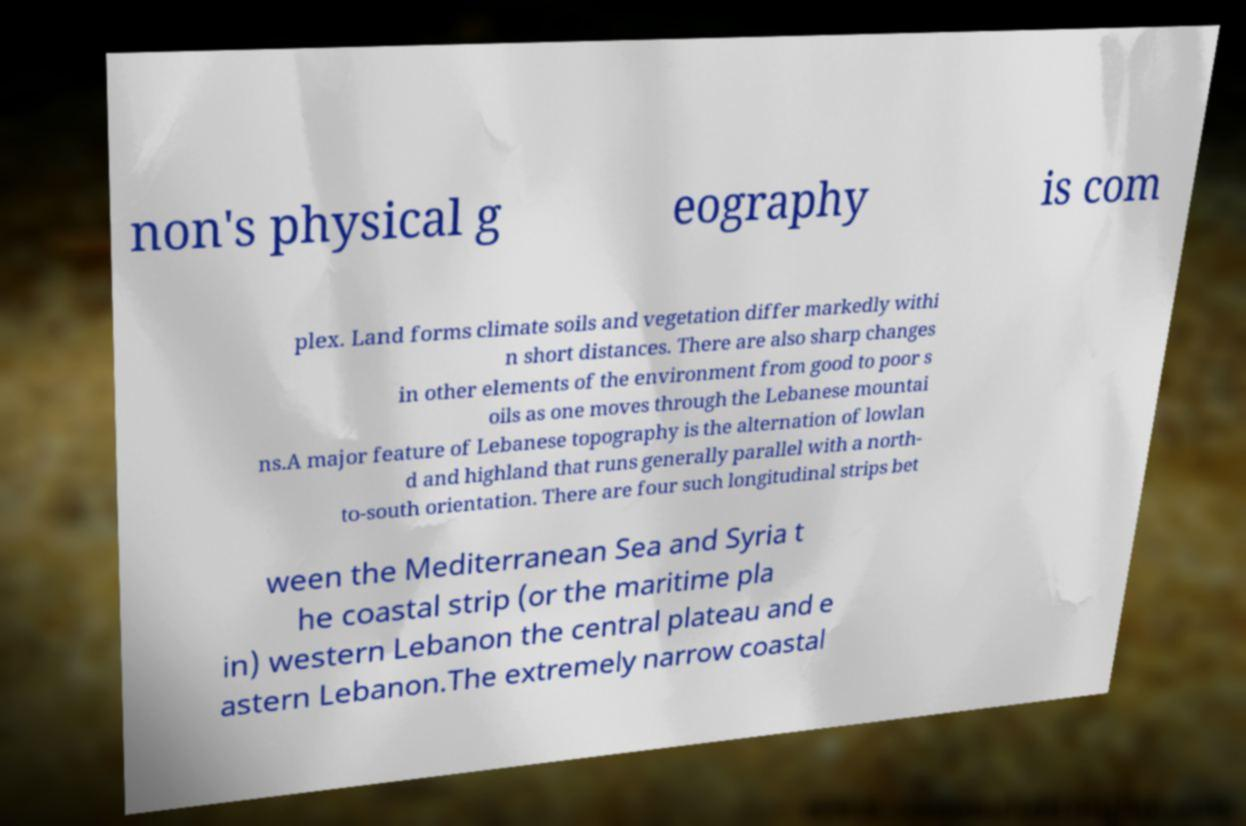Could you extract and type out the text from this image? non's physical g eography is com plex. Land forms climate soils and vegetation differ markedly withi n short distances. There are also sharp changes in other elements of the environment from good to poor s oils as one moves through the Lebanese mountai ns.A major feature of Lebanese topography is the alternation of lowlan d and highland that runs generally parallel with a north- to-south orientation. There are four such longitudinal strips bet ween the Mediterranean Sea and Syria t he coastal strip (or the maritime pla in) western Lebanon the central plateau and e astern Lebanon.The extremely narrow coastal 